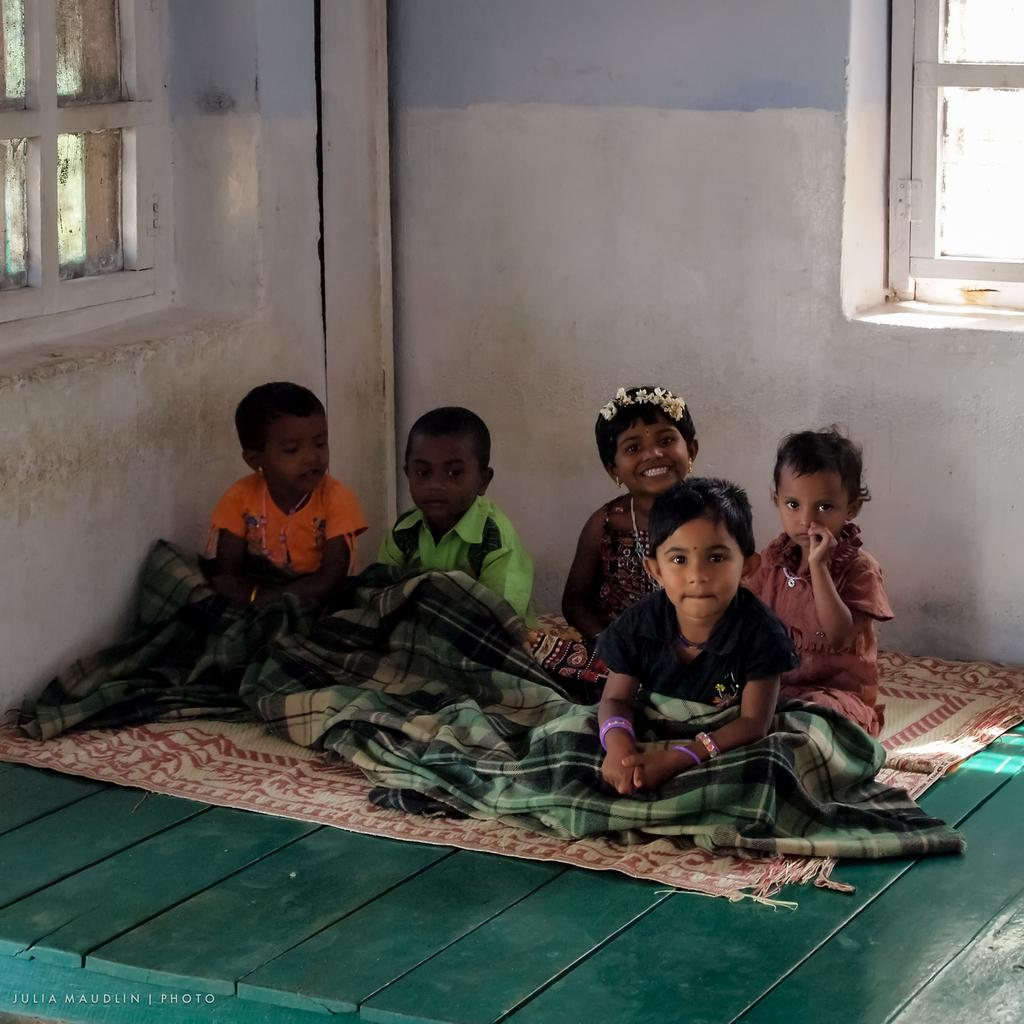How many kids are present in the image? There are five kids in the image. What are the kids sitting on? The kids are sitting on a wooden table. What are the kids wearing? The kids are wearing blankets. What can be seen in the background of the image? There is a wall in the background of the image, and windows are on the wall. What type of garden can be seen in the image? There is no garden present in the image. What season is depicted in the image? The provided facts do not indicate the season depicted in the image. 